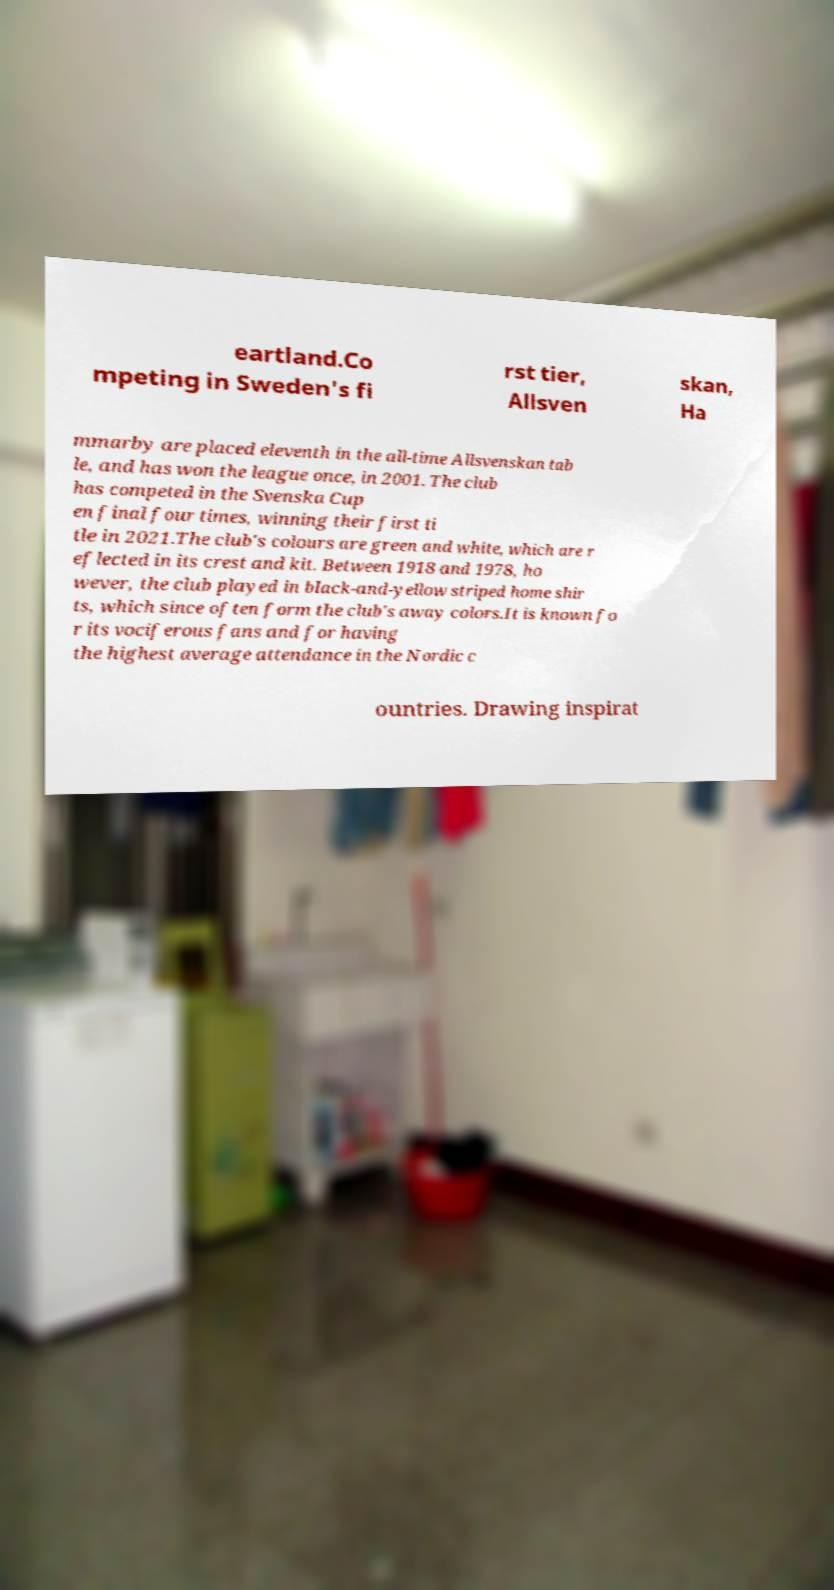For documentation purposes, I need the text within this image transcribed. Could you provide that? eartland.Co mpeting in Sweden's fi rst tier, Allsven skan, Ha mmarby are placed eleventh in the all-time Allsvenskan tab le, and has won the league once, in 2001. The club has competed in the Svenska Cup en final four times, winning their first ti tle in 2021.The club's colours are green and white, which are r eflected in its crest and kit. Between 1918 and 1978, ho wever, the club played in black-and-yellow striped home shir ts, which since often form the club's away colors.It is known fo r its vociferous fans and for having the highest average attendance in the Nordic c ountries. Drawing inspirat 